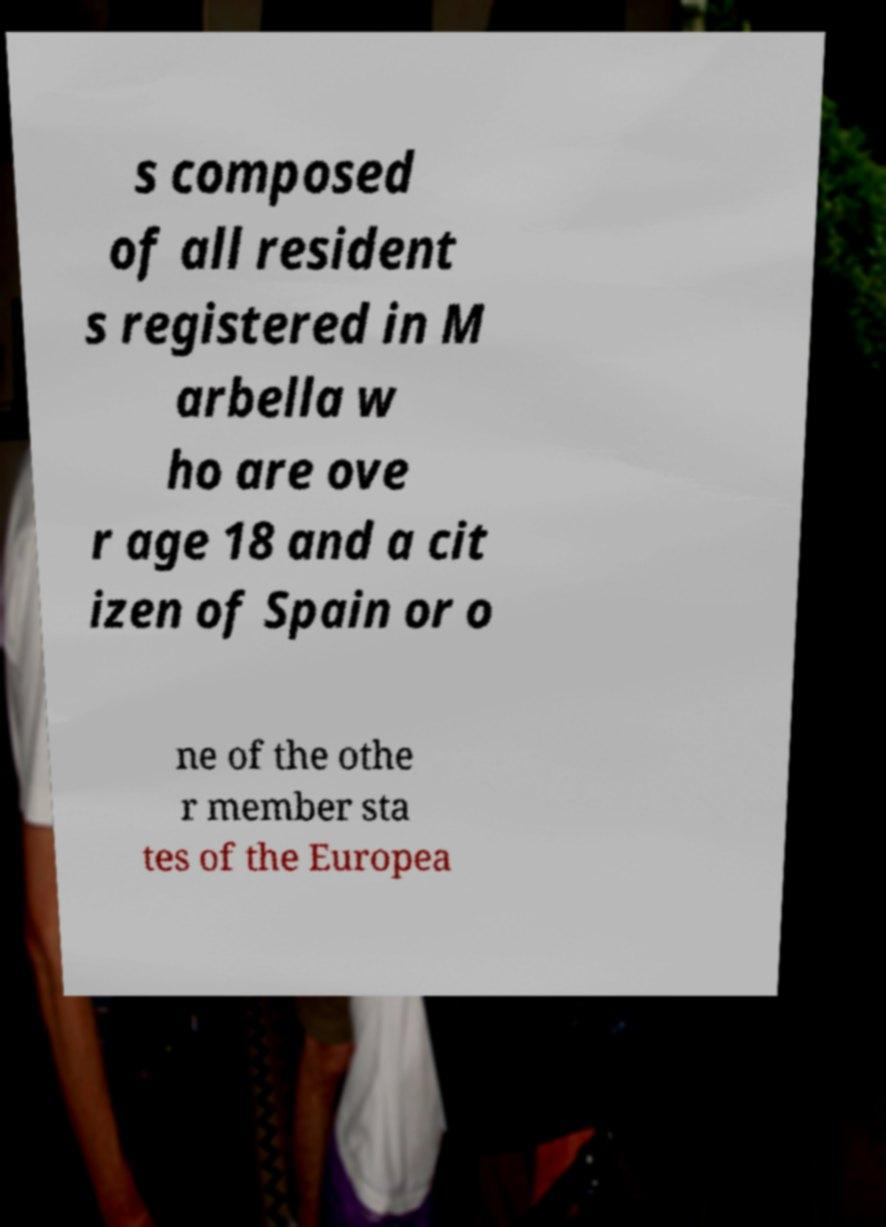For documentation purposes, I need the text within this image transcribed. Could you provide that? s composed of all resident s registered in M arbella w ho are ove r age 18 and a cit izen of Spain or o ne of the othe r member sta tes of the Europea 